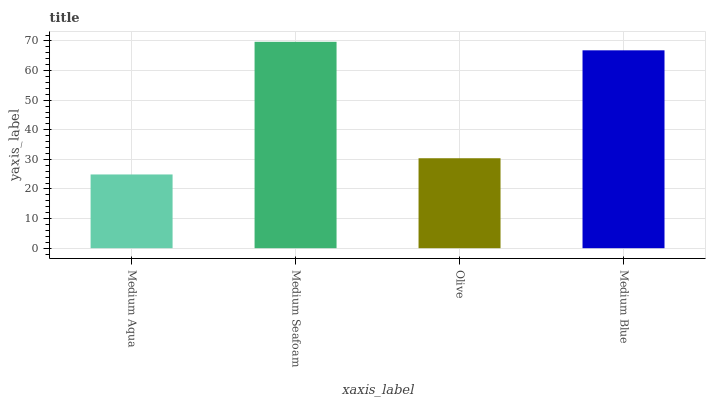Is Medium Aqua the minimum?
Answer yes or no. Yes. Is Medium Seafoam the maximum?
Answer yes or no. Yes. Is Olive the minimum?
Answer yes or no. No. Is Olive the maximum?
Answer yes or no. No. Is Medium Seafoam greater than Olive?
Answer yes or no. Yes. Is Olive less than Medium Seafoam?
Answer yes or no. Yes. Is Olive greater than Medium Seafoam?
Answer yes or no. No. Is Medium Seafoam less than Olive?
Answer yes or no. No. Is Medium Blue the high median?
Answer yes or no. Yes. Is Olive the low median?
Answer yes or no. Yes. Is Medium Aqua the high median?
Answer yes or no. No. Is Medium Blue the low median?
Answer yes or no. No. 